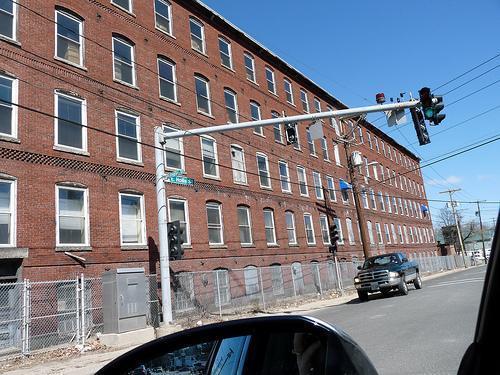How many cars on the street?
Give a very brief answer. 2. 